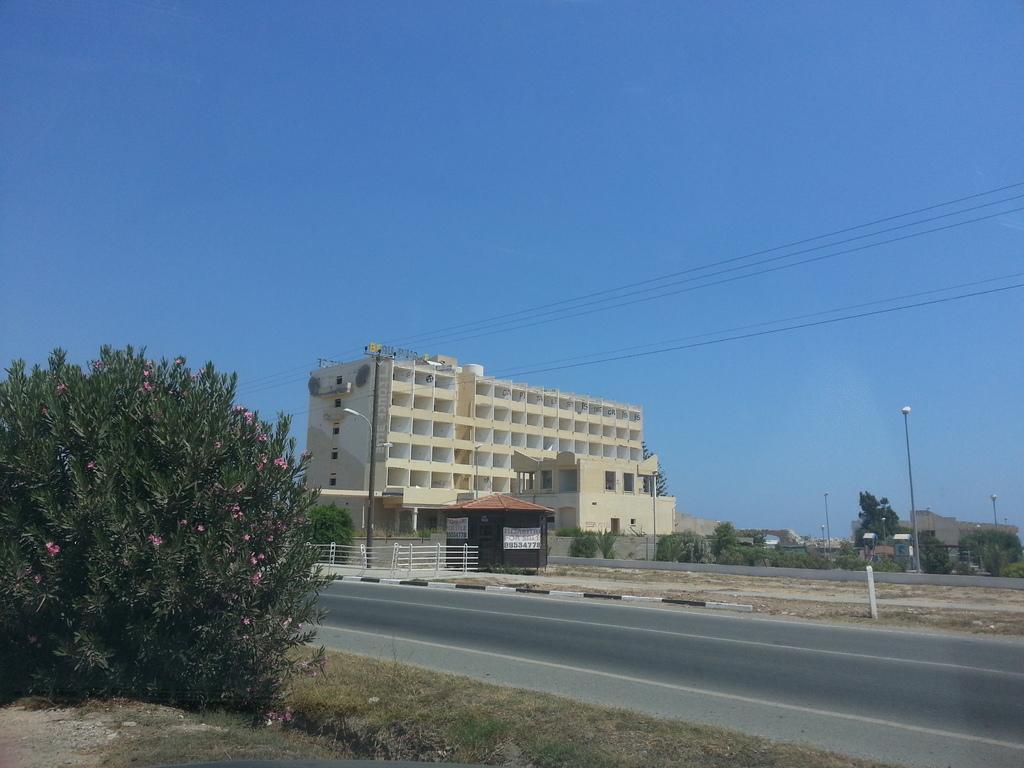In one or two sentences, can you explain what this image depicts? In this image we can see a building, street poles, plants, grass, the pathway, a fence, banners, poles, a group of trees, wires and the sky. 